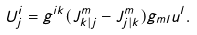<formula> <loc_0><loc_0><loc_500><loc_500>U ^ { i } _ { j } = g ^ { i k } ( J ^ { m } _ { k | j } - J ^ { m } _ { j | k } ) g _ { m l } u ^ { l } .</formula> 